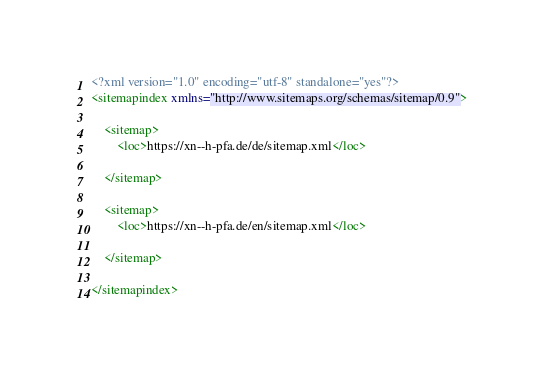Convert code to text. <code><loc_0><loc_0><loc_500><loc_500><_XML_><?xml version="1.0" encoding="utf-8" standalone="yes"?>
<sitemapindex xmlns="http://www.sitemaps.org/schemas/sitemap/0.9">
	
	<sitemap>
	   	<loc>https://xn--h-pfa.de/de/sitemap.xml</loc>
		
	</sitemap>
	
	<sitemap>
	   	<loc>https://xn--h-pfa.de/en/sitemap.xml</loc>
		
	</sitemap>
	
</sitemapindex>
</code> 